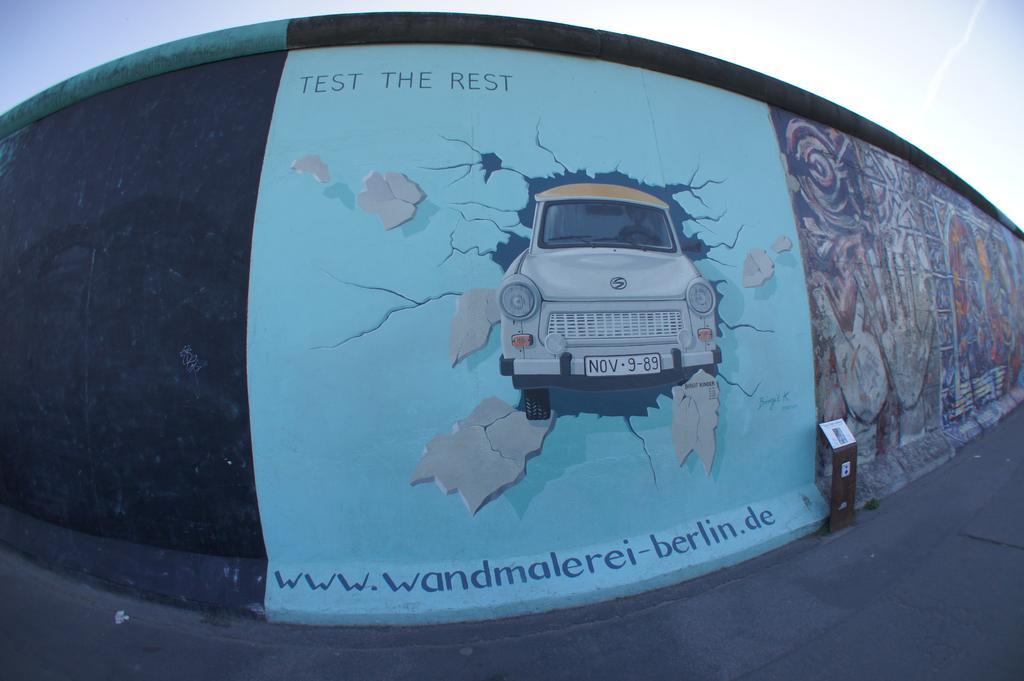Describe this image in one or two sentences. This is the zoom-in picture of the wall, on which paintings are there. One painting is of car with some text written and the other one is multiple color painting. And in front of the wall one road is there and one stand is present. 